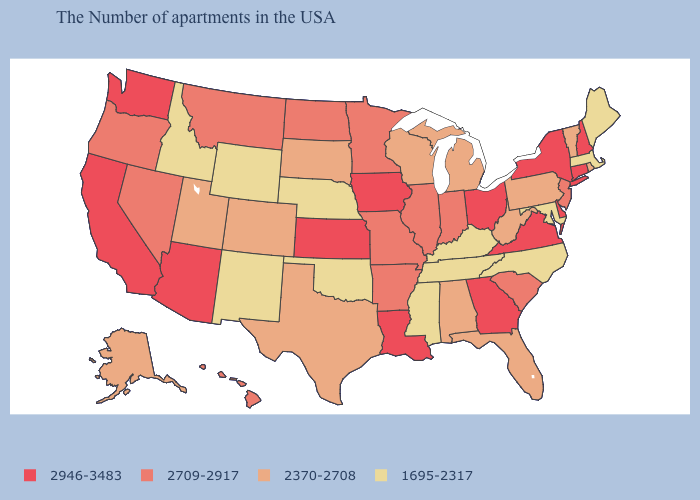Does Nebraska have the lowest value in the MidWest?
Concise answer only. Yes. How many symbols are there in the legend?
Quick response, please. 4. What is the value of South Dakota?
Short answer required. 2370-2708. What is the lowest value in the USA?
Answer briefly. 1695-2317. Name the states that have a value in the range 2946-3483?
Concise answer only. New Hampshire, Connecticut, New York, Delaware, Virginia, Ohio, Georgia, Louisiana, Iowa, Kansas, Arizona, California, Washington. What is the highest value in the USA?
Write a very short answer. 2946-3483. Name the states that have a value in the range 2370-2708?
Concise answer only. Rhode Island, Vermont, Pennsylvania, West Virginia, Florida, Michigan, Alabama, Wisconsin, Texas, South Dakota, Colorado, Utah, Alaska. What is the value of Texas?
Concise answer only. 2370-2708. Does Massachusetts have a lower value than Maine?
Quick response, please. No. Name the states that have a value in the range 2709-2917?
Concise answer only. New Jersey, South Carolina, Indiana, Illinois, Missouri, Arkansas, Minnesota, North Dakota, Montana, Nevada, Oregon, Hawaii. Does the map have missing data?
Short answer required. No. What is the value of Montana?
Be succinct. 2709-2917. What is the lowest value in states that border Texas?
Give a very brief answer. 1695-2317. 